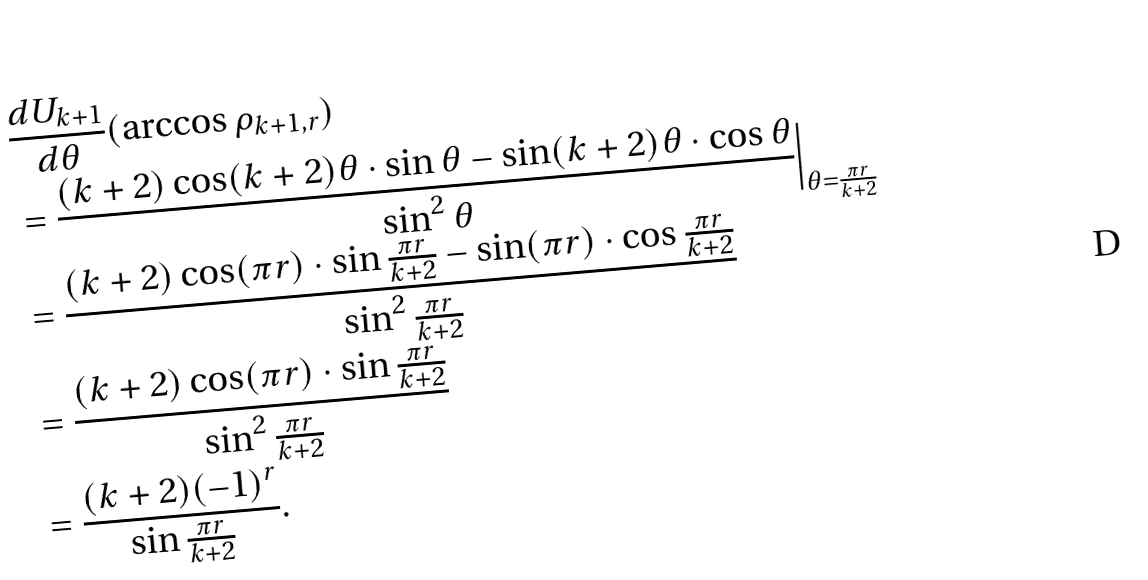<formula> <loc_0><loc_0><loc_500><loc_500>& \frac { d U _ { k + 1 } } { d \theta } ( \arccos \rho _ { k + 1 , r } ) \\ & = \frac { ( k + 2 ) \cos ( k + 2 ) \theta \cdot \sin \theta - \sin ( k + 2 ) \theta \cdot \cos \theta } { \sin ^ { 2 } \theta } \Big | _ { \theta = \frac { \pi r } { k + 2 } } \\ & = \frac { ( k + 2 ) \cos ( \pi r ) \cdot \sin \frac { \pi r } { k + 2 } - \sin ( \pi r ) \cdot \cos \frac { \pi r } { k + 2 } } { \sin ^ { 2 } \frac { \pi r } { k + 2 } } \\ & = \frac { ( k + 2 ) \cos ( \pi r ) \cdot \sin \frac { \pi r } { k + 2 } } { \sin ^ { 2 } \frac { \pi r } { k + 2 } } \\ & = \frac { ( k + 2 ) ( - 1 ) ^ { r } } { \sin \frac { \pi r } { k + 2 } } .</formula> 